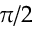<formula> <loc_0><loc_0><loc_500><loc_500>\pi / 2</formula> 